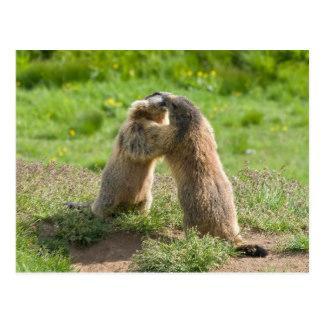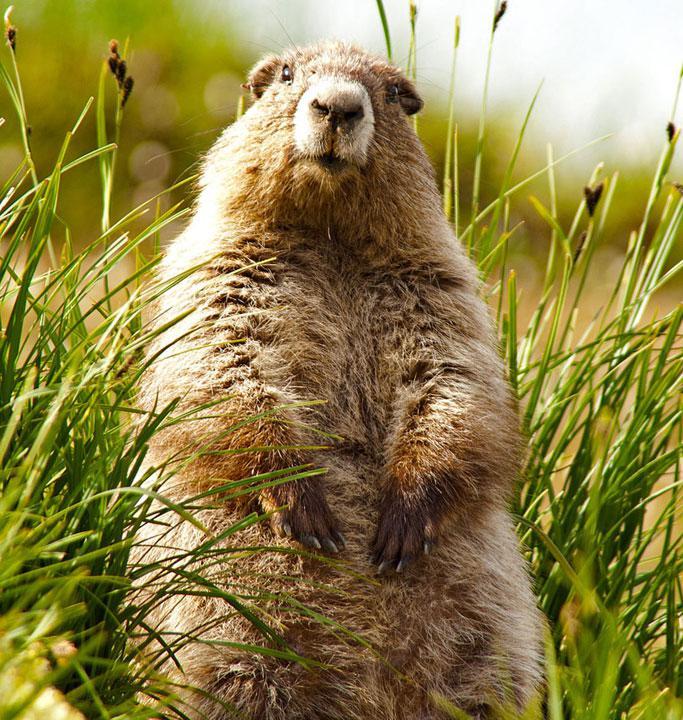The first image is the image on the left, the second image is the image on the right. For the images displayed, is the sentence "Marmots are standing on hind legs facing each other" factually correct? Answer yes or no. Yes. 